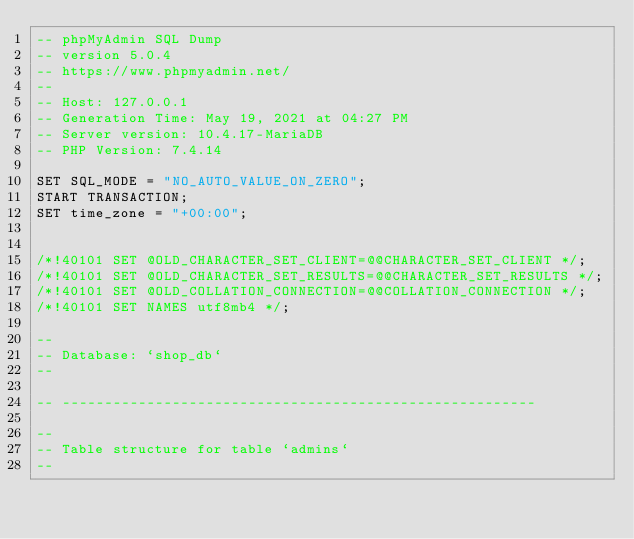<code> <loc_0><loc_0><loc_500><loc_500><_SQL_>-- phpMyAdmin SQL Dump
-- version 5.0.4
-- https://www.phpmyadmin.net/
--
-- Host: 127.0.0.1
-- Generation Time: May 19, 2021 at 04:27 PM
-- Server version: 10.4.17-MariaDB
-- PHP Version: 7.4.14

SET SQL_MODE = "NO_AUTO_VALUE_ON_ZERO";
START TRANSACTION;
SET time_zone = "+00:00";


/*!40101 SET @OLD_CHARACTER_SET_CLIENT=@@CHARACTER_SET_CLIENT */;
/*!40101 SET @OLD_CHARACTER_SET_RESULTS=@@CHARACTER_SET_RESULTS */;
/*!40101 SET @OLD_COLLATION_CONNECTION=@@COLLATION_CONNECTION */;
/*!40101 SET NAMES utf8mb4 */;

--
-- Database: `shop_db`
--

-- --------------------------------------------------------

--
-- Table structure for table `admins`
--
</code> 